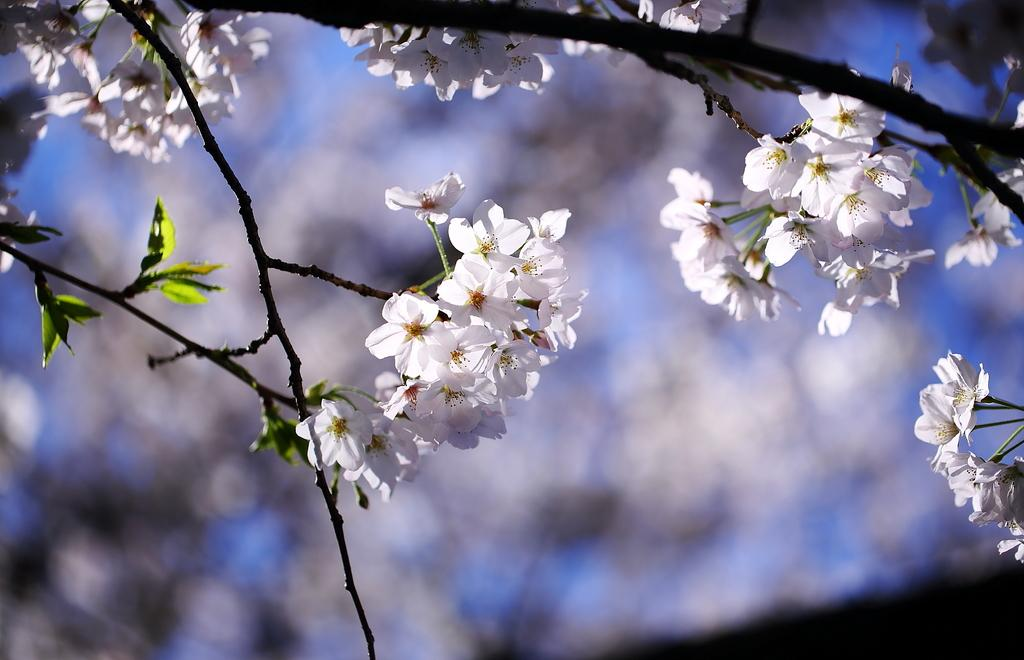What is present in the image? There is a tree in the image. What can be observed about the tree's flowers? The tree has white flowers. What type of metal can be seen in the image? There is no metal present in the image; it only features a tree with white flowers. What letters can be seen on the tree in the image? There are no letters present on the tree in the image. 